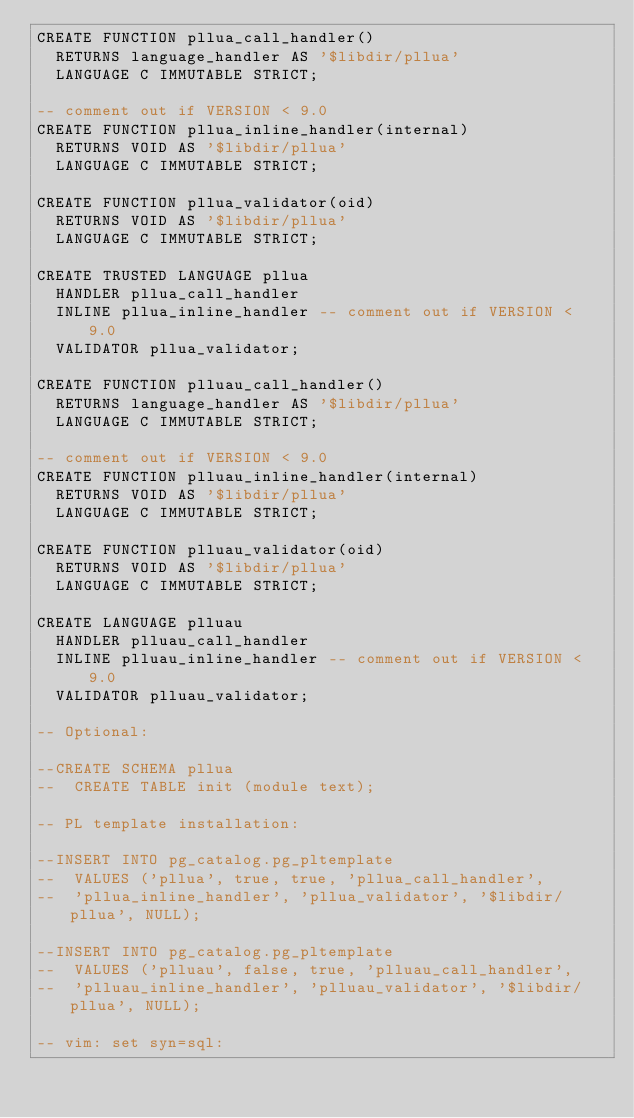Convert code to text. <code><loc_0><loc_0><loc_500><loc_500><_SQL_>CREATE FUNCTION pllua_call_handler()
  RETURNS language_handler AS '$libdir/pllua'
  LANGUAGE C IMMUTABLE STRICT;

-- comment out if VERSION < 9.0
CREATE FUNCTION pllua_inline_handler(internal)
  RETURNS VOID AS '$libdir/pllua'
  LANGUAGE C IMMUTABLE STRICT;

CREATE FUNCTION pllua_validator(oid)
  RETURNS VOID AS '$libdir/pllua'
  LANGUAGE C IMMUTABLE STRICT;

CREATE TRUSTED LANGUAGE pllua
  HANDLER pllua_call_handler
  INLINE pllua_inline_handler -- comment out if VERSION < 9.0
  VALIDATOR pllua_validator;

CREATE FUNCTION plluau_call_handler()
  RETURNS language_handler AS '$libdir/pllua'
  LANGUAGE C IMMUTABLE STRICT;

-- comment out if VERSION < 9.0
CREATE FUNCTION plluau_inline_handler(internal)
  RETURNS VOID AS '$libdir/pllua'
  LANGUAGE C IMMUTABLE STRICT;

CREATE FUNCTION plluau_validator(oid)
  RETURNS VOID AS '$libdir/pllua'
  LANGUAGE C IMMUTABLE STRICT;

CREATE LANGUAGE plluau
  HANDLER plluau_call_handler
  INLINE plluau_inline_handler -- comment out if VERSION < 9.0
  VALIDATOR plluau_validator;

-- Optional:

--CREATE SCHEMA pllua
--  CREATE TABLE init (module text);

-- PL template installation:

--INSERT INTO pg_catalog.pg_pltemplate
--  VALUES ('pllua', true, true, 'pllua_call_handler',
--  'pllua_inline_handler', 'pllua_validator', '$libdir/pllua', NULL);

--INSERT INTO pg_catalog.pg_pltemplate
--  VALUES ('plluau', false, true, 'plluau_call_handler',
--  'plluau_inline_handler', 'plluau_validator', '$libdir/pllua', NULL);

-- vim: set syn=sql:
</code> 